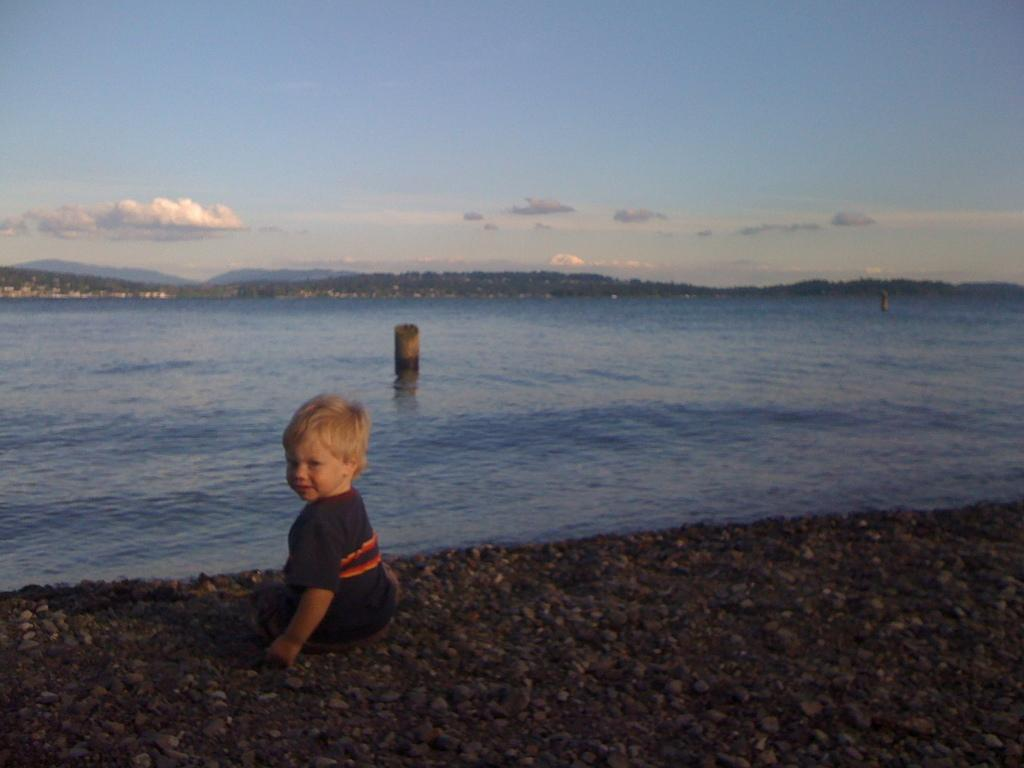What is the kid doing in the image? The kid is seated on the stones in the image. What can be seen in the background of the image? There is water, trees, and clouds visible in the background of the image. What type of sponge is being used by the visitor in the image? There is no visitor or sponge present in the image. How does the net help the kid in the image? There is no net present in the image, so it cannot help the kid. 